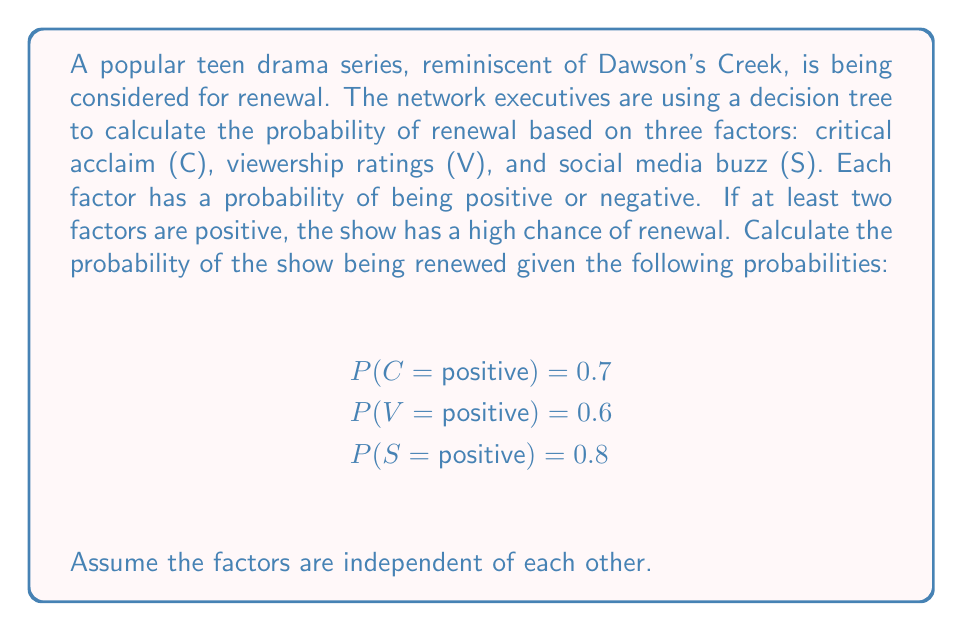Give your solution to this math problem. To solve this problem, we'll use a decision tree approach similar to how network executives might analyze the renewal chances of a show like Dawson's Creek. We need to calculate the probability of at least two factors being positive.

Let's break it down step-by-step:

1) First, let's calculate the probability of each factor being negative:
   P(C = negative) = 1 - 0.7 = 0.3
   P(V = negative) = 1 - 0.6 = 0.4
   P(S = negative) = 1 - 0.8 = 0.2

2) Now, we need to consider all scenarios where at least two factors are positive. These are:
   - All three positive (C+, V+, S+)
   - Two positive, one negative (C+, V+, S-), (C+, V-, S+), (C-, V+, S+)

3) Let's calculate the probability of each scenario:
   P(C+, V+, S+) = 0.7 * 0.6 * 0.8 = 0.336
   P(C+, V+, S-) = 0.7 * 0.6 * 0.2 = 0.084
   P(C+, V-, S+) = 0.7 * 0.4 * 0.8 = 0.224
   P(C-, V+, S+) = 0.3 * 0.6 * 0.8 = 0.144

4) The total probability of renewal is the sum of these probabilities:

   P(renewal) = P(C+, V+, S+) + P(C+, V+, S-) + P(C+, V-, S+) + P(C-, V+, S+)
               = 0.336 + 0.084 + 0.224 + 0.144
               = 0.788

Therefore, the probability of the show being renewed is 0.788 or 78.8%.
Answer: The probability of the show being renewed is 0.788 or 78.8%. 